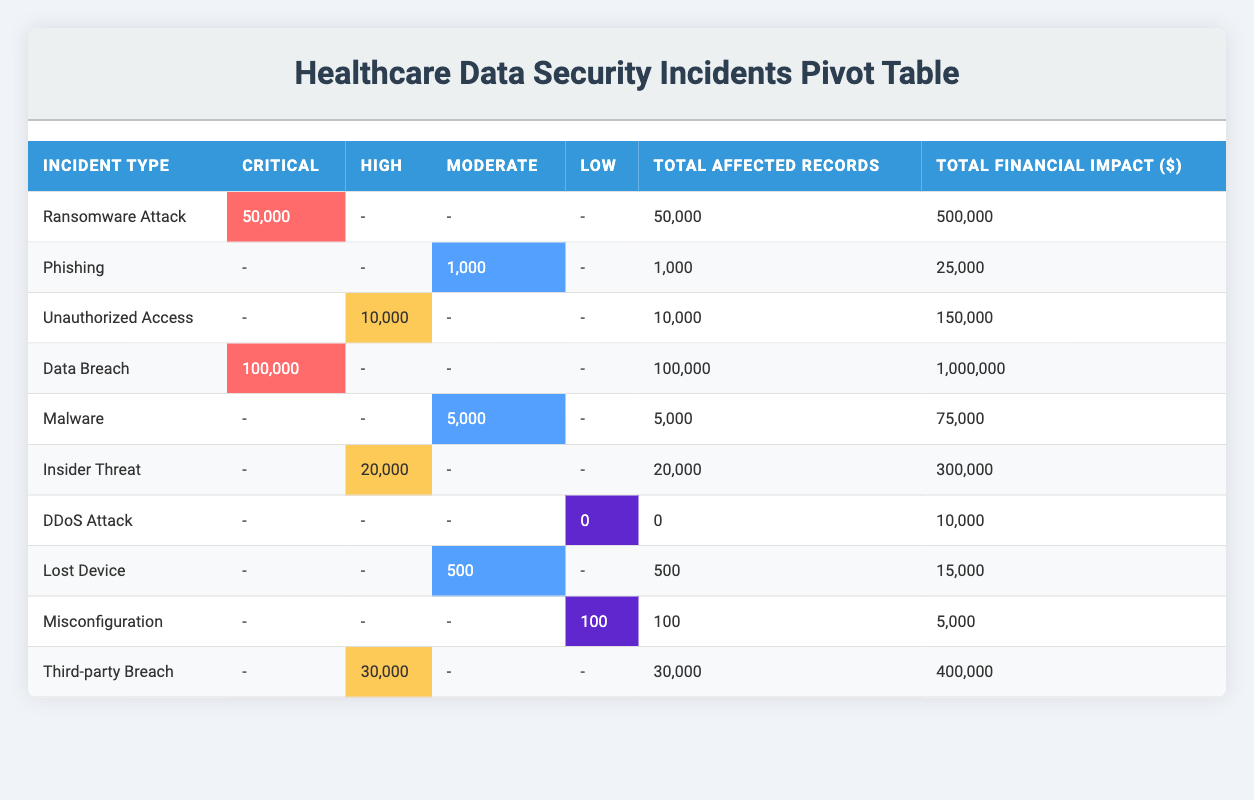What is the total number of affected records for Ransomware Attacks? From the table, the row for Ransomware Attack shows that 50,000 records were affected.
Answer: 50,000 How many incidents have a financial impact greater than $100,000? By reviewing the financial impact column, the incidents exceeding $100,000 are the Data Breach ($1,000,000), Ransomware Attack ($500,000), Insider Threat ($300,000), and Third-party Breach ($400,000), totaling 4 incidents.
Answer: 4 Which incident type has the highest number of affected records? The Data Breach incident type reports the highest number of affected records with 100,000, compared to others which have lower counts, such as Ransomware Attack (50,000) and Insider Threat (20,000).
Answer: Data Breach What is the average resolution time for incidents categorized as Moderate severity? The resolution times for Moderate severity incidents (Phishing 24 hours, Malware 36 hours, Lost Device 8 hours) are summed up as 24 + 36 + 8 = 68 hours. There are 3 incidents, so the average resolution time is 68 / 3 = 22.67 hours.
Answer: 22.67 hours Did any incidents report a total financial impact of less than $20,000? The incidents listed show that only the DDoS Attack ($10,000) and Lost Device ($15,000) report financial impacts under $20,000, confirming that yes, there are incidents with low financial impacts.
Answer: Yes What is the total financial impact of incidents categorized as High severity? The financial impacts for High severity incidents include Unauthorized Access ($150,000), Insider Threat ($300,000), and Third-party Breach ($400,000). Adding these amounts, 150,000 + 300,000 + 400,000 = 850,000 gives a total of $850,000.
Answer: $850,000 Which department experienced the most critical incidents? The table indicates that the Critical incidents were in Radiology (Ransomware Attack) and Emergency (Data Breach). Both departments experienced one critical incident each; thus, there is no clear winner as they both have one critical incident.
Answer: No clear winner How many total records were affected by incidents classified as Low severity? From the table, there are two Low severity incidents – DDoS Attack (0 records) and Misconfiguration (100 records). Therefore, the total affected records are 0 + 100 = 100.
Answer: 100 What proportion of incidents resulted in a resolution time of more than 70 hours? The incidents with a resolution time greater than 70 hours are Ransomware Attack (72 hours), Data Breach (96 hours), and Third-party Breach (84 hours). There are 10 incidents total, which means the proportion is 3 out of 10, equating to 30%.
Answer: 30% 